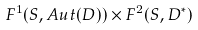Convert formula to latex. <formula><loc_0><loc_0><loc_500><loc_500>F ^ { 1 } ( S , A u t ( D ) ) \times F ^ { 2 } ( S , D ^ { * } )</formula> 